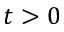<formula> <loc_0><loc_0><loc_500><loc_500>t > 0</formula> 